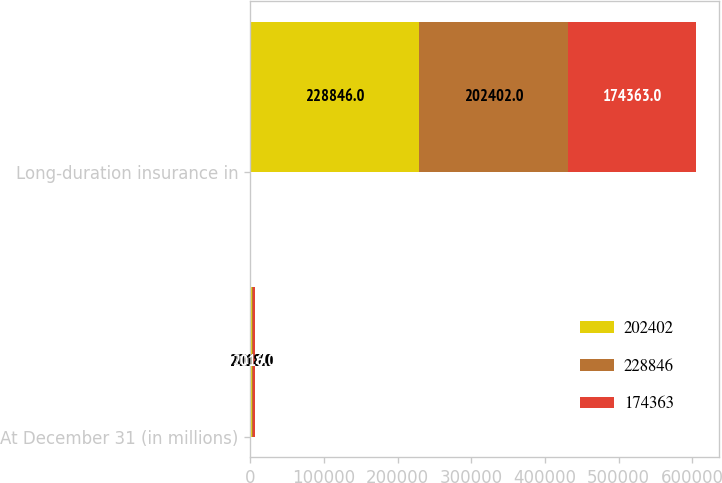Convert chart to OTSL. <chart><loc_0><loc_0><loc_500><loc_500><stacked_bar_chart><ecel><fcel>At December 31 (in millions)<fcel>Long-duration insurance in<nl><fcel>202402<fcel>2018<fcel>228846<nl><fcel>228846<fcel>2017<fcel>202402<nl><fcel>174363<fcel>2016<fcel>174363<nl></chart> 